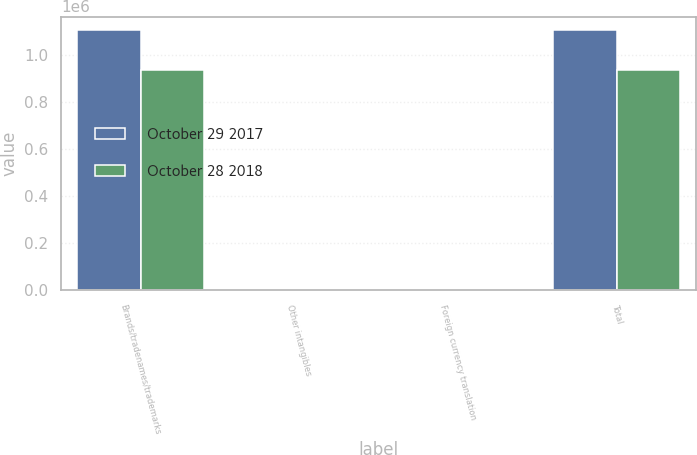Convert chart to OTSL. <chart><loc_0><loc_0><loc_500><loc_500><stacked_bar_chart><ecel><fcel>Brands/tradenames/trademarks<fcel>Other intangibles<fcel>Foreign currency translation<fcel>Total<nl><fcel>October 29 2017<fcel>1.10812e+06<fcel>184<fcel>3484<fcel>1.10482e+06<nl><fcel>October 28 2018<fcel>935816<fcel>184<fcel>9<fcel>935991<nl></chart> 